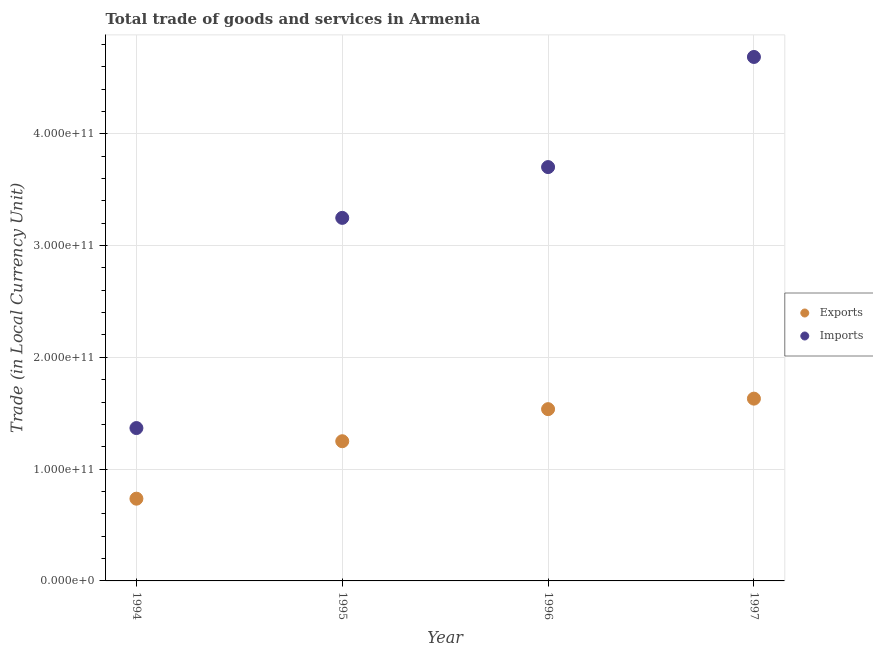Is the number of dotlines equal to the number of legend labels?
Your response must be concise. Yes. What is the imports of goods and services in 1994?
Make the answer very short. 1.37e+11. Across all years, what is the maximum export of goods and services?
Your response must be concise. 1.63e+11. Across all years, what is the minimum export of goods and services?
Ensure brevity in your answer.  7.36e+1. In which year was the imports of goods and services maximum?
Your response must be concise. 1997. In which year was the imports of goods and services minimum?
Your answer should be compact. 1994. What is the total imports of goods and services in the graph?
Provide a succinct answer. 1.30e+12. What is the difference between the export of goods and services in 1994 and that in 1997?
Offer a very short reply. -8.95e+1. What is the difference between the export of goods and services in 1997 and the imports of goods and services in 1994?
Offer a terse response. 2.63e+1. What is the average export of goods and services per year?
Your response must be concise. 1.29e+11. In the year 1995, what is the difference between the imports of goods and services and export of goods and services?
Offer a terse response. 2.00e+11. In how many years, is the export of goods and services greater than 120000000000 LCU?
Your answer should be compact. 3. What is the ratio of the imports of goods and services in 1994 to that in 1996?
Provide a succinct answer. 0.37. Is the imports of goods and services in 1995 less than that in 1997?
Make the answer very short. Yes. What is the difference between the highest and the second highest imports of goods and services?
Ensure brevity in your answer.  9.85e+1. What is the difference between the highest and the lowest export of goods and services?
Provide a short and direct response. 8.95e+1. Is the export of goods and services strictly less than the imports of goods and services over the years?
Keep it short and to the point. Yes. What is the difference between two consecutive major ticks on the Y-axis?
Ensure brevity in your answer.  1.00e+11. Does the graph contain any zero values?
Give a very brief answer. No. Does the graph contain grids?
Provide a short and direct response. Yes. Where does the legend appear in the graph?
Your response must be concise. Center right. How many legend labels are there?
Make the answer very short. 2. What is the title of the graph?
Your response must be concise. Total trade of goods and services in Armenia. Does "From production" appear as one of the legend labels in the graph?
Give a very brief answer. No. What is the label or title of the Y-axis?
Offer a terse response. Trade (in Local Currency Unit). What is the Trade (in Local Currency Unit) in Exports in 1994?
Give a very brief answer. 7.36e+1. What is the Trade (in Local Currency Unit) of Imports in 1994?
Provide a short and direct response. 1.37e+11. What is the Trade (in Local Currency Unit) of Exports in 1995?
Provide a short and direct response. 1.25e+11. What is the Trade (in Local Currency Unit) of Imports in 1995?
Your answer should be compact. 3.25e+11. What is the Trade (in Local Currency Unit) in Exports in 1996?
Make the answer very short. 1.54e+11. What is the Trade (in Local Currency Unit) in Imports in 1996?
Give a very brief answer. 3.70e+11. What is the Trade (in Local Currency Unit) in Exports in 1997?
Make the answer very short. 1.63e+11. What is the Trade (in Local Currency Unit) in Imports in 1997?
Give a very brief answer. 4.69e+11. Across all years, what is the maximum Trade (in Local Currency Unit) of Exports?
Offer a very short reply. 1.63e+11. Across all years, what is the maximum Trade (in Local Currency Unit) of Imports?
Give a very brief answer. 4.69e+11. Across all years, what is the minimum Trade (in Local Currency Unit) of Exports?
Keep it short and to the point. 7.36e+1. Across all years, what is the minimum Trade (in Local Currency Unit) in Imports?
Offer a very short reply. 1.37e+11. What is the total Trade (in Local Currency Unit) in Exports in the graph?
Offer a very short reply. 5.15e+11. What is the total Trade (in Local Currency Unit) of Imports in the graph?
Give a very brief answer. 1.30e+12. What is the difference between the Trade (in Local Currency Unit) of Exports in 1994 and that in 1995?
Give a very brief answer. -5.14e+1. What is the difference between the Trade (in Local Currency Unit) in Imports in 1994 and that in 1995?
Ensure brevity in your answer.  -1.88e+11. What is the difference between the Trade (in Local Currency Unit) of Exports in 1994 and that in 1996?
Your answer should be very brief. -8.01e+1. What is the difference between the Trade (in Local Currency Unit) in Imports in 1994 and that in 1996?
Provide a succinct answer. -2.33e+11. What is the difference between the Trade (in Local Currency Unit) in Exports in 1994 and that in 1997?
Offer a terse response. -8.95e+1. What is the difference between the Trade (in Local Currency Unit) in Imports in 1994 and that in 1997?
Your answer should be very brief. -3.32e+11. What is the difference between the Trade (in Local Currency Unit) in Exports in 1995 and that in 1996?
Provide a succinct answer. -2.87e+1. What is the difference between the Trade (in Local Currency Unit) in Imports in 1995 and that in 1996?
Make the answer very short. -4.54e+1. What is the difference between the Trade (in Local Currency Unit) of Exports in 1995 and that in 1997?
Keep it short and to the point. -3.81e+1. What is the difference between the Trade (in Local Currency Unit) in Imports in 1995 and that in 1997?
Offer a terse response. -1.44e+11. What is the difference between the Trade (in Local Currency Unit) in Exports in 1996 and that in 1997?
Ensure brevity in your answer.  -9.40e+09. What is the difference between the Trade (in Local Currency Unit) in Imports in 1996 and that in 1997?
Offer a terse response. -9.85e+1. What is the difference between the Trade (in Local Currency Unit) in Exports in 1994 and the Trade (in Local Currency Unit) in Imports in 1995?
Provide a succinct answer. -2.51e+11. What is the difference between the Trade (in Local Currency Unit) of Exports in 1994 and the Trade (in Local Currency Unit) of Imports in 1996?
Your answer should be very brief. -2.97e+11. What is the difference between the Trade (in Local Currency Unit) of Exports in 1994 and the Trade (in Local Currency Unit) of Imports in 1997?
Your answer should be very brief. -3.95e+11. What is the difference between the Trade (in Local Currency Unit) in Exports in 1995 and the Trade (in Local Currency Unit) in Imports in 1996?
Offer a terse response. -2.45e+11. What is the difference between the Trade (in Local Currency Unit) in Exports in 1995 and the Trade (in Local Currency Unit) in Imports in 1997?
Make the answer very short. -3.44e+11. What is the difference between the Trade (in Local Currency Unit) in Exports in 1996 and the Trade (in Local Currency Unit) in Imports in 1997?
Make the answer very short. -3.15e+11. What is the average Trade (in Local Currency Unit) of Exports per year?
Make the answer very short. 1.29e+11. What is the average Trade (in Local Currency Unit) of Imports per year?
Your answer should be compact. 3.25e+11. In the year 1994, what is the difference between the Trade (in Local Currency Unit) of Exports and Trade (in Local Currency Unit) of Imports?
Ensure brevity in your answer.  -6.32e+1. In the year 1995, what is the difference between the Trade (in Local Currency Unit) in Exports and Trade (in Local Currency Unit) in Imports?
Offer a very short reply. -2.00e+11. In the year 1996, what is the difference between the Trade (in Local Currency Unit) in Exports and Trade (in Local Currency Unit) in Imports?
Provide a short and direct response. -2.17e+11. In the year 1997, what is the difference between the Trade (in Local Currency Unit) in Exports and Trade (in Local Currency Unit) in Imports?
Your answer should be compact. -3.06e+11. What is the ratio of the Trade (in Local Currency Unit) in Exports in 1994 to that in 1995?
Offer a very short reply. 0.59. What is the ratio of the Trade (in Local Currency Unit) in Imports in 1994 to that in 1995?
Give a very brief answer. 0.42. What is the ratio of the Trade (in Local Currency Unit) of Exports in 1994 to that in 1996?
Your answer should be compact. 0.48. What is the ratio of the Trade (in Local Currency Unit) of Imports in 1994 to that in 1996?
Ensure brevity in your answer.  0.37. What is the ratio of the Trade (in Local Currency Unit) of Exports in 1994 to that in 1997?
Offer a terse response. 0.45. What is the ratio of the Trade (in Local Currency Unit) in Imports in 1994 to that in 1997?
Your answer should be very brief. 0.29. What is the ratio of the Trade (in Local Currency Unit) in Exports in 1995 to that in 1996?
Make the answer very short. 0.81. What is the ratio of the Trade (in Local Currency Unit) of Imports in 1995 to that in 1996?
Offer a very short reply. 0.88. What is the ratio of the Trade (in Local Currency Unit) of Exports in 1995 to that in 1997?
Ensure brevity in your answer.  0.77. What is the ratio of the Trade (in Local Currency Unit) of Imports in 1995 to that in 1997?
Offer a very short reply. 0.69. What is the ratio of the Trade (in Local Currency Unit) of Exports in 1996 to that in 1997?
Give a very brief answer. 0.94. What is the ratio of the Trade (in Local Currency Unit) in Imports in 1996 to that in 1997?
Your answer should be compact. 0.79. What is the difference between the highest and the second highest Trade (in Local Currency Unit) of Exports?
Ensure brevity in your answer.  9.40e+09. What is the difference between the highest and the second highest Trade (in Local Currency Unit) in Imports?
Provide a succinct answer. 9.85e+1. What is the difference between the highest and the lowest Trade (in Local Currency Unit) in Exports?
Offer a terse response. 8.95e+1. What is the difference between the highest and the lowest Trade (in Local Currency Unit) in Imports?
Your answer should be very brief. 3.32e+11. 